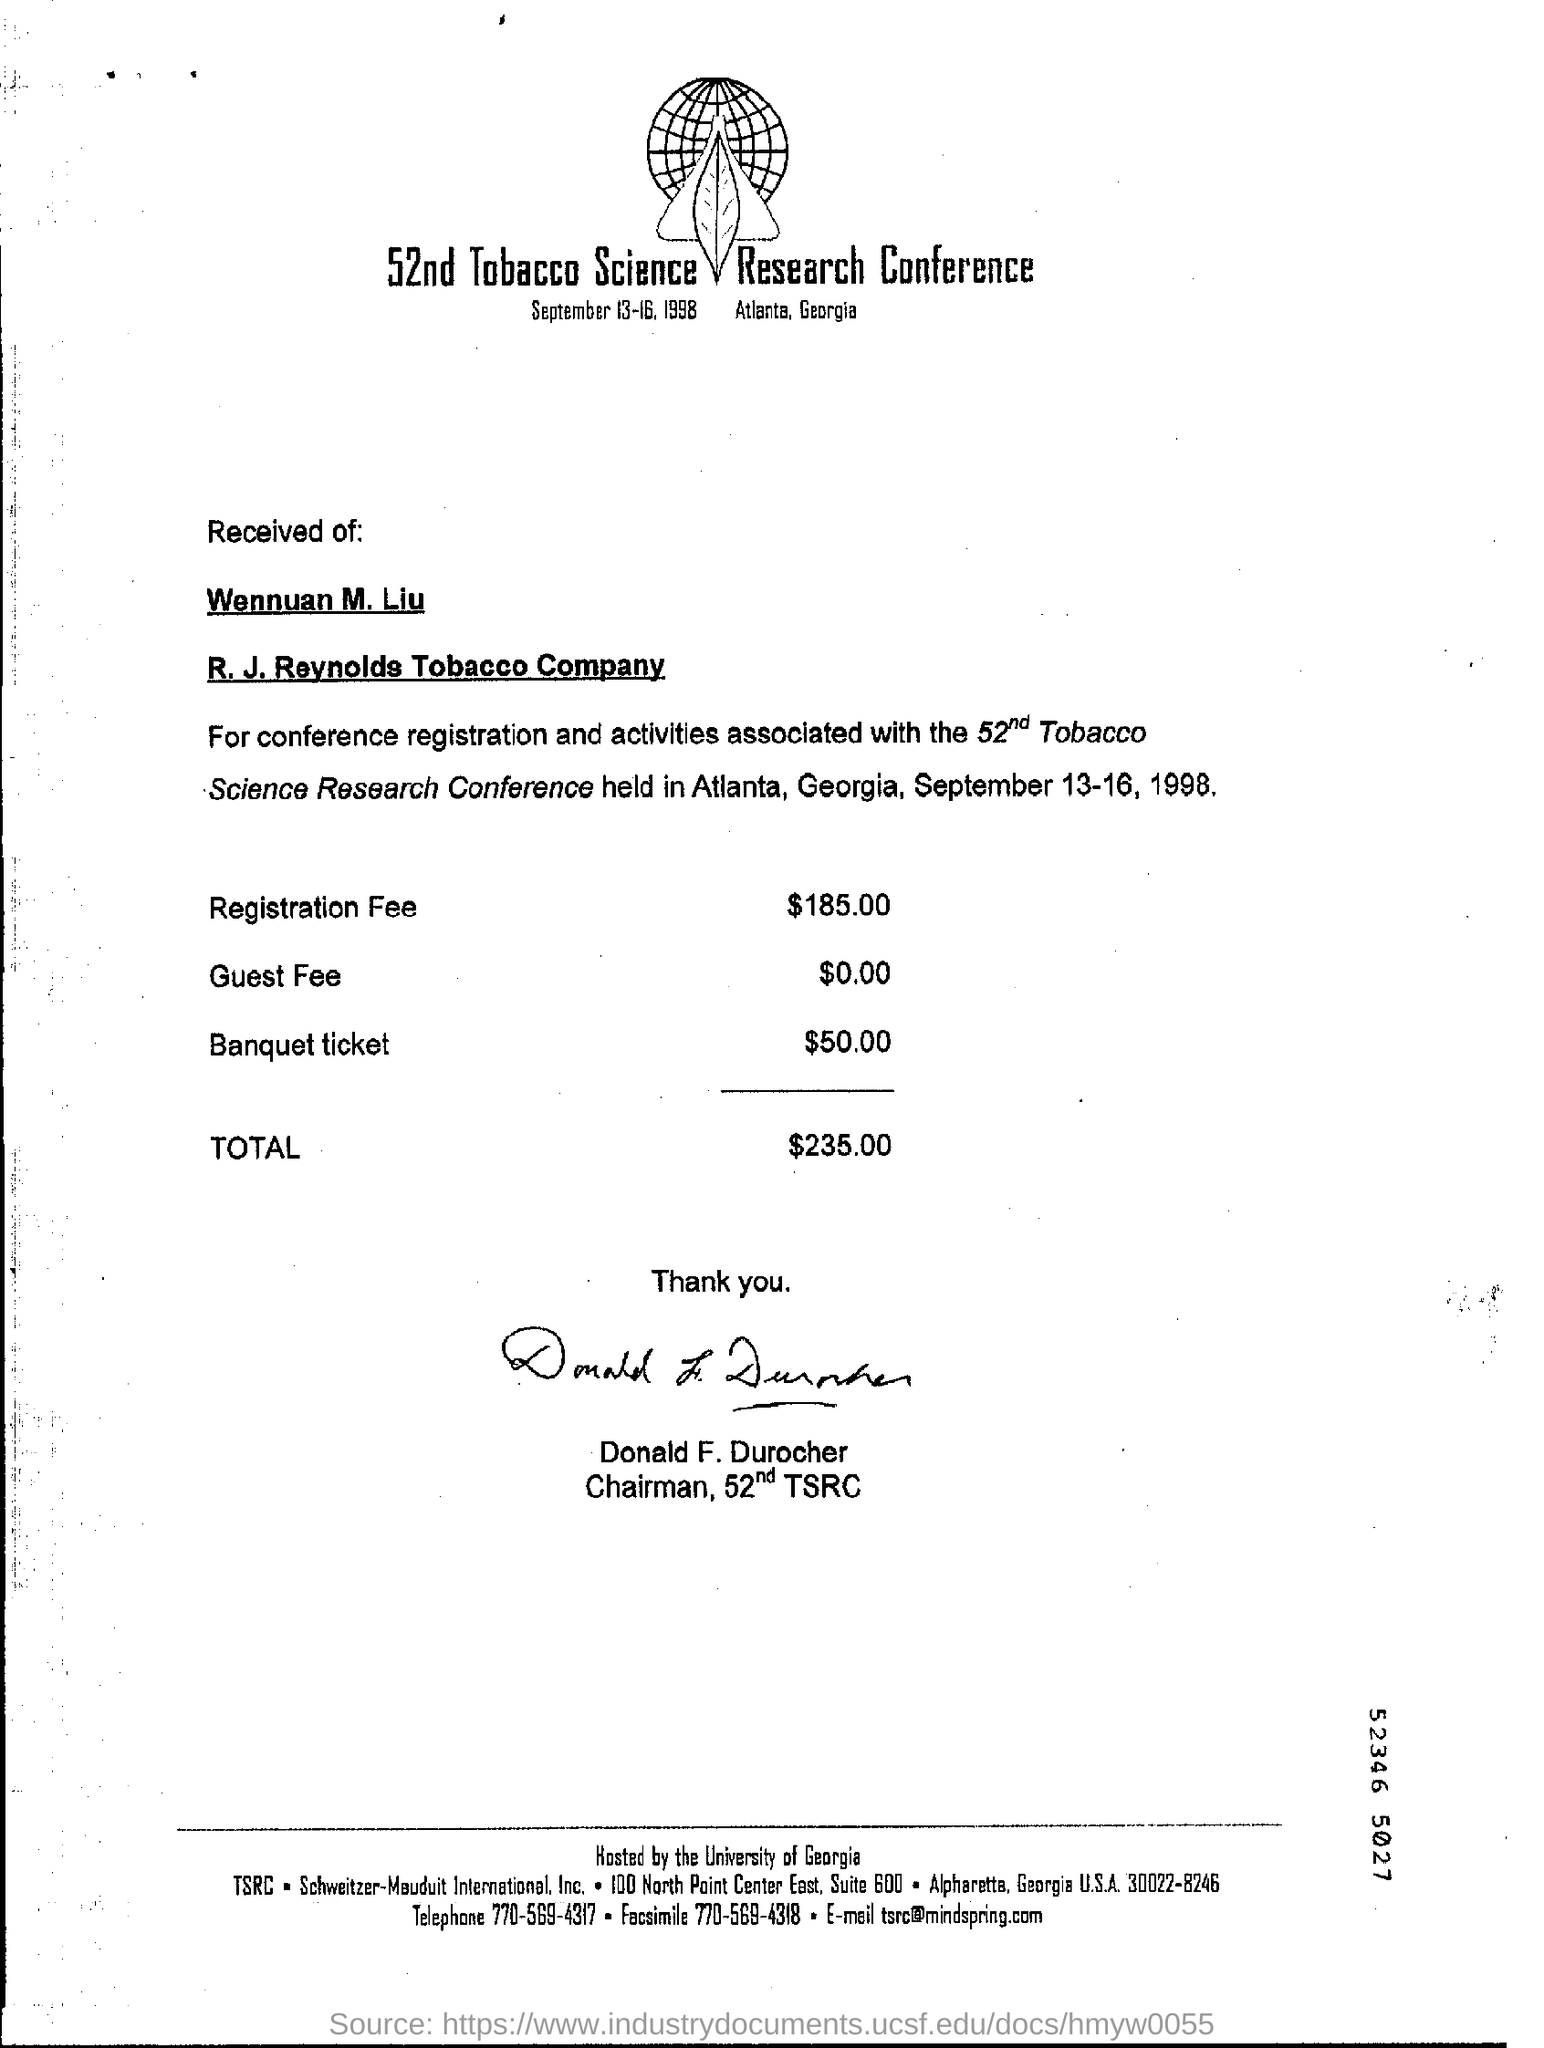Point out several critical features in this image. The chairman of this conference is Donald F. Durocher. The dates of the conference were from September 13 to 16, 1998. The registration fee for the conference is $185.00. 